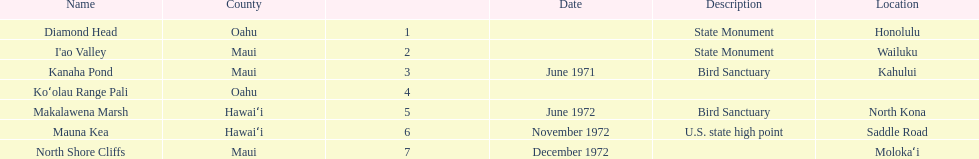What are the total number of landmarks located in maui? 3. 